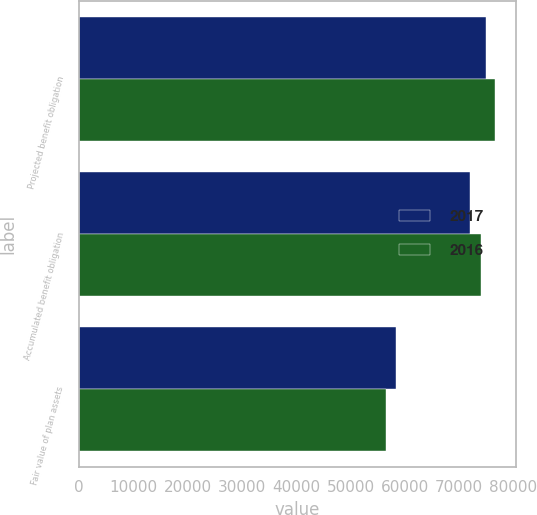Convert chart to OTSL. <chart><loc_0><loc_0><loc_500><loc_500><stacked_bar_chart><ecel><fcel>Projected benefit obligation<fcel>Accumulated benefit obligation<fcel>Fair value of plan assets<nl><fcel>2017<fcel>74953<fcel>71975<fcel>58353<nl><fcel>2016<fcel>76586<fcel>74081<fcel>56530<nl></chart> 